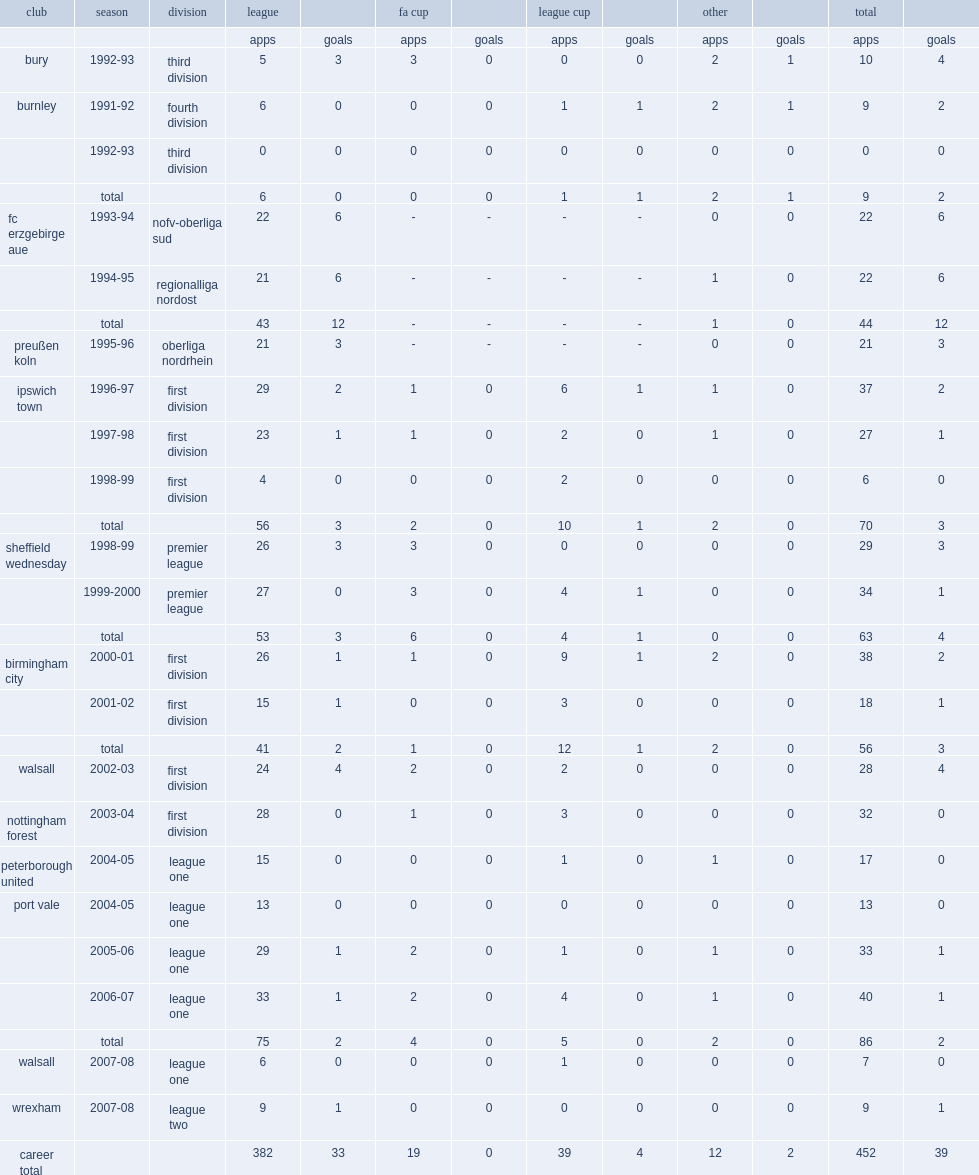Which club did danny sonner appear for, in the league one, in the 2004-05 season? Peterborough united. 